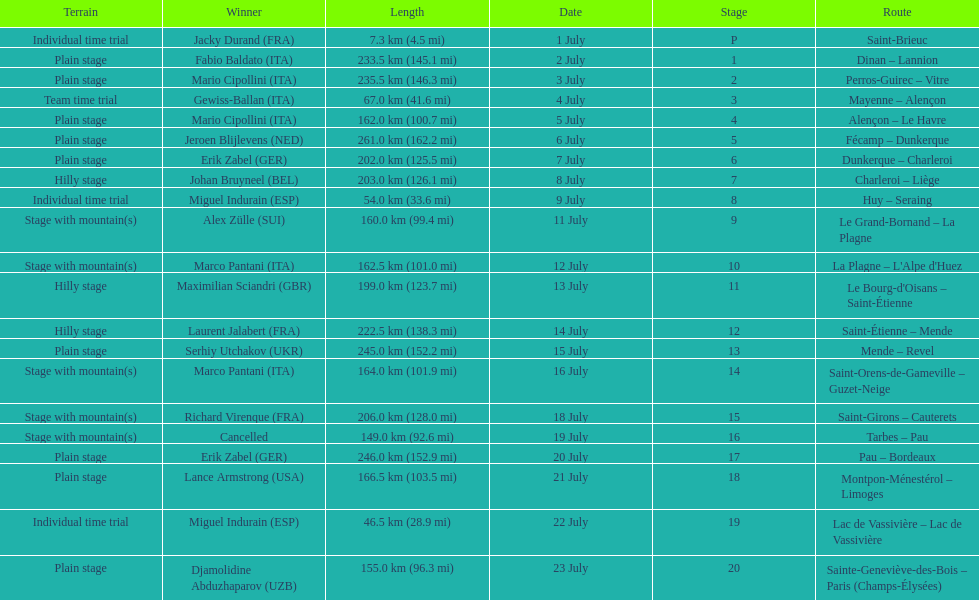How many consecutive km were raced on july 8th? 203.0 km (126.1 mi). 